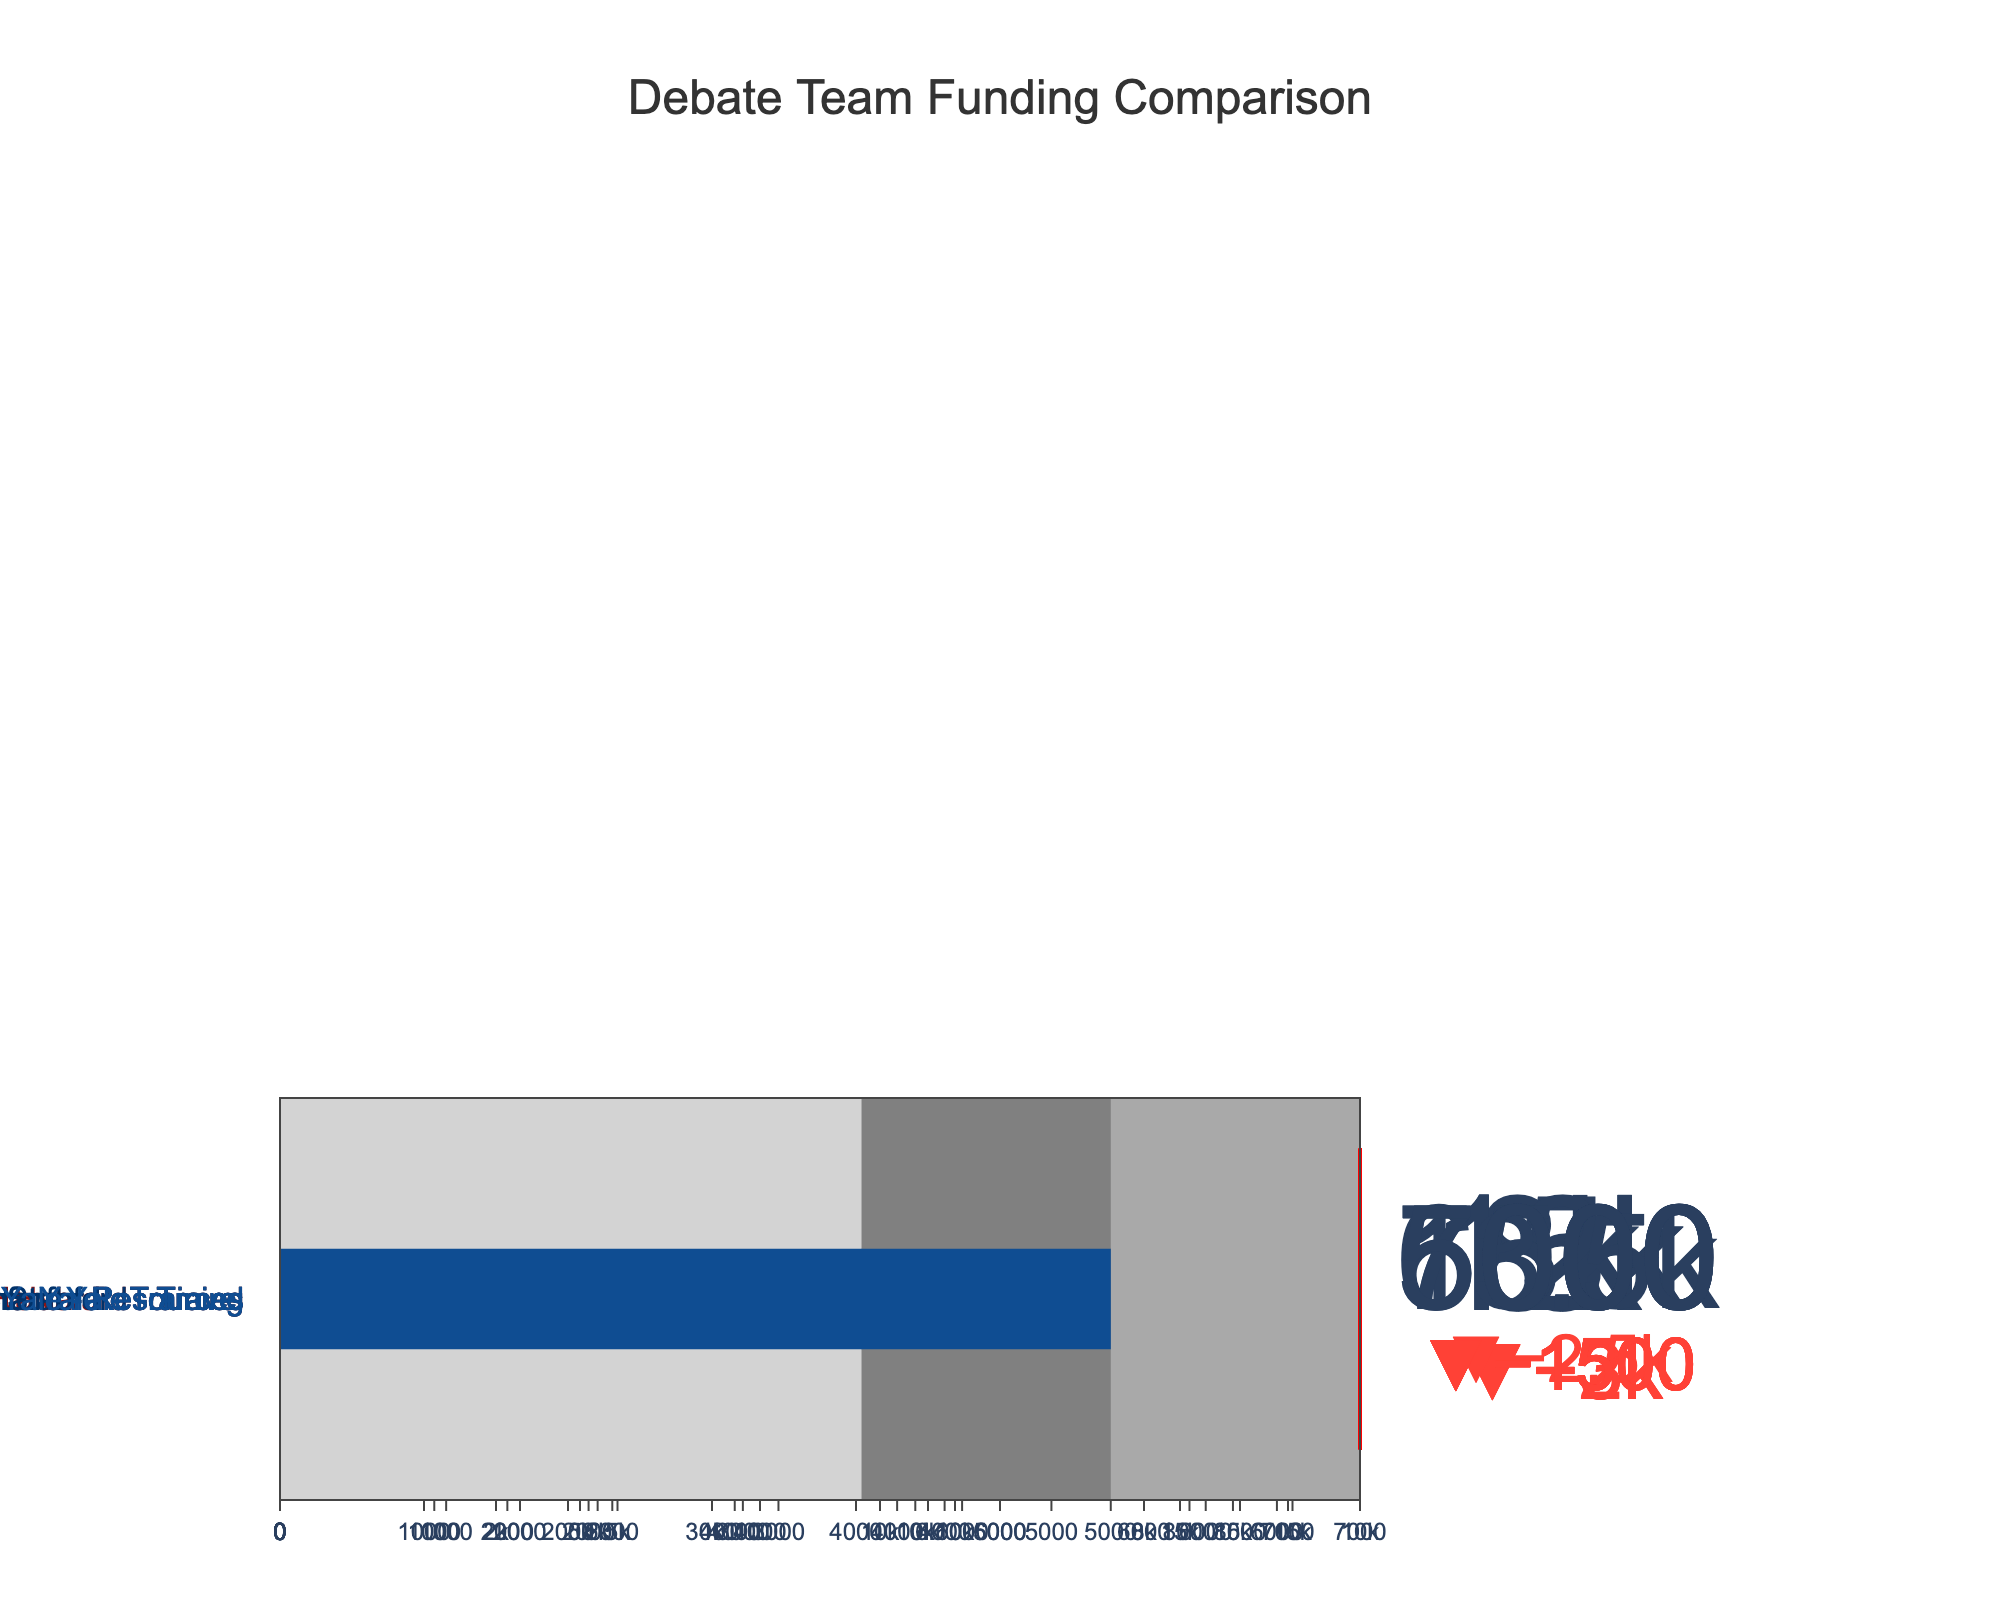What is the title of the chart? The title of the chart is displayed at the top of the figure, indicating what the data represents. The question is asking for this descriptive heading.
Answer: Debate Team Funding Comparison Which school has the highest actual spending on travel? By examining the bullet charts for travel across the different schools, you can compare the actual spending values. The highest value should be identified.
Answer: Harvard How does Harvard's actual spending on training compare to its target? Look at Harvard's bullet chart for training, specifically the actual spending marker and the position of the target line, to determine whether it meets, exceeds, or is below the target.
Answer: Below target Which category for Yale has the narrowest range? To identify the category with the narrowest range for Yale, compare the difference between Range3 and 0 for each category (Travel, Training, Resources).
Answer: Resources What is the average target budget for travel across all schools? The target budgets for travel across the three schools are [18000, 15000, 16000]. Summing these values and dividing by 3 gives the average. (18000 + 15000 + 16000) / 3 = 16333.33
Answer: 16333.33 Does Stanford's actual spending meet or exceed the target for resources? According to the bullet chart for Stanford's resources, compare the actual spending marker to the target position to determine if it meets or exceeds.
Answer: Meets the target Which school has the lowest actual spending on resources? Review the actual spending markers on the bullet charts for resources for each school and identify the lowest value.
Answer: Yale How much more does Yale spend on training compared to its lowest range boundary? Find Yale's actual spending for training and subtract it by the lowest range boundary value for training. (7000 - 5000)
Answer: 2000 How does the target budget for Harvard's travel compare to its highest range boundary? Compare Harvard's target budget value for travel with the highest range boundary (Range3) to see if it is equal to, above, or below it.
Answer: Equal to 